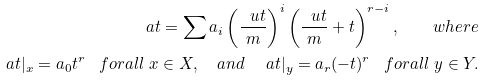Convert formula to latex. <formula><loc_0><loc_0><loc_500><loc_500>\ a t = \sum a _ { i } \left ( \frac { \ u t } { m } \right ) ^ { i } \left ( \frac { \ u t } { m } + t \right ) ^ { r - i } , \quad w h e r e \\ \ a t | _ { x } = a _ { 0 } t ^ { r } \ \ \ f o r a l l \ x \in X , \quad a n d \quad \ a t | _ { y } = a _ { r } ( - t ) ^ { r } \ \ \ f o r a l l \ y \in Y .</formula> 